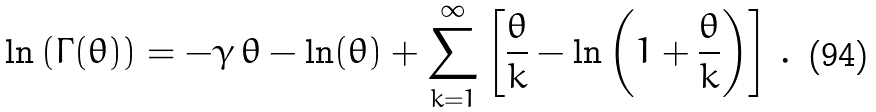Convert formula to latex. <formula><loc_0><loc_0><loc_500><loc_500>\ln \left ( \Gamma ( \theta ) \right ) = - \gamma \, \theta - \ln ( \theta ) + \sum _ { k = 1 } ^ { \infty } \left [ \frac { \theta } { k } - \ln \left ( 1 + \frac { \theta } { k } \right ) \right ] \, .</formula> 